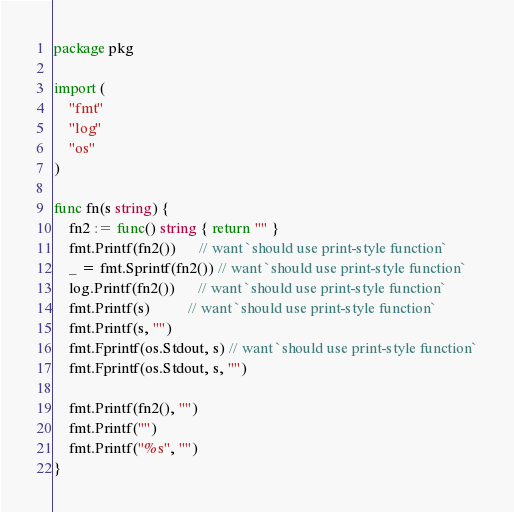Convert code to text. <code><loc_0><loc_0><loc_500><loc_500><_Go_>package pkg

import (
	"fmt"
	"log"
	"os"
)

func fn(s string) {
	fn2 := func() string { return "" }
	fmt.Printf(fn2())      // want `should use print-style function`
	_ = fmt.Sprintf(fn2()) // want `should use print-style function`
	log.Printf(fn2())      // want `should use print-style function`
	fmt.Printf(s)          // want `should use print-style function`
	fmt.Printf(s, "")
	fmt.Fprintf(os.Stdout, s) // want `should use print-style function`
	fmt.Fprintf(os.Stdout, s, "")

	fmt.Printf(fn2(), "")
	fmt.Printf("")
	fmt.Printf("%s", "")
}
</code> 